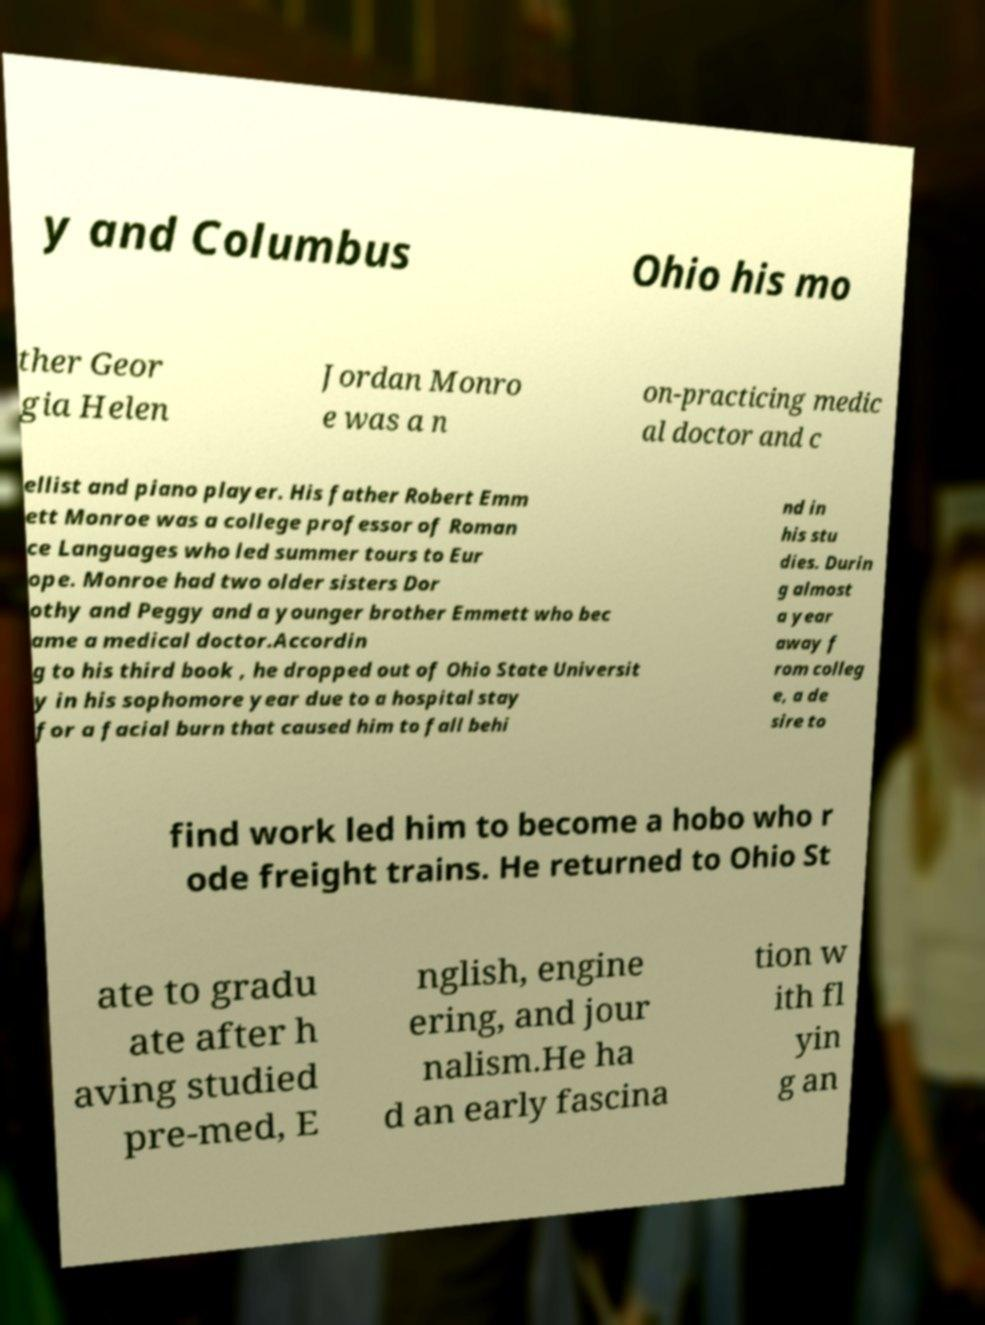Please identify and transcribe the text found in this image. y and Columbus Ohio his mo ther Geor gia Helen Jordan Monro e was a n on-practicing medic al doctor and c ellist and piano player. His father Robert Emm ett Monroe was a college professor of Roman ce Languages who led summer tours to Eur ope. Monroe had two older sisters Dor othy and Peggy and a younger brother Emmett who bec ame a medical doctor.Accordin g to his third book , he dropped out of Ohio State Universit y in his sophomore year due to a hospital stay for a facial burn that caused him to fall behi nd in his stu dies. Durin g almost a year away f rom colleg e, a de sire to find work led him to become a hobo who r ode freight trains. He returned to Ohio St ate to gradu ate after h aving studied pre-med, E nglish, engine ering, and jour nalism.He ha d an early fascina tion w ith fl yin g an 